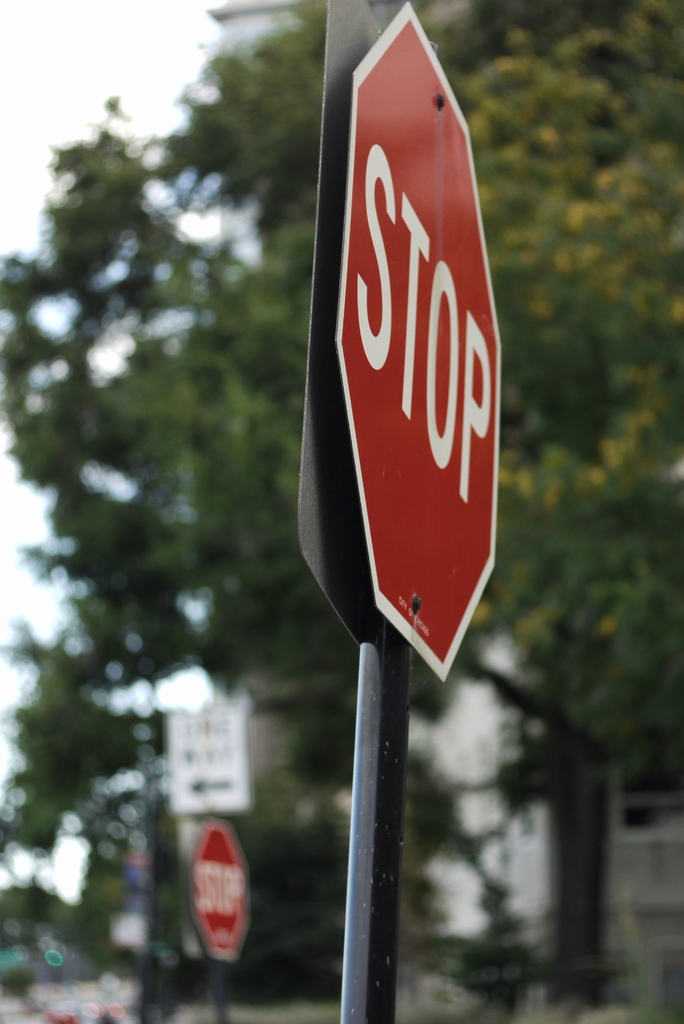Is there anything about this stop sign that stands out to you? Certainly, beyond its vivid red color and stark white lettering, one notable feature is the sign's pristine condition, suggesting it might be relatively new or well-maintained. Additionally, the second stop sign in the background adds a layer of depth to the image and implies the photographer's intention to capture more than just the object—it suggests a pattern or system in place in this area. 